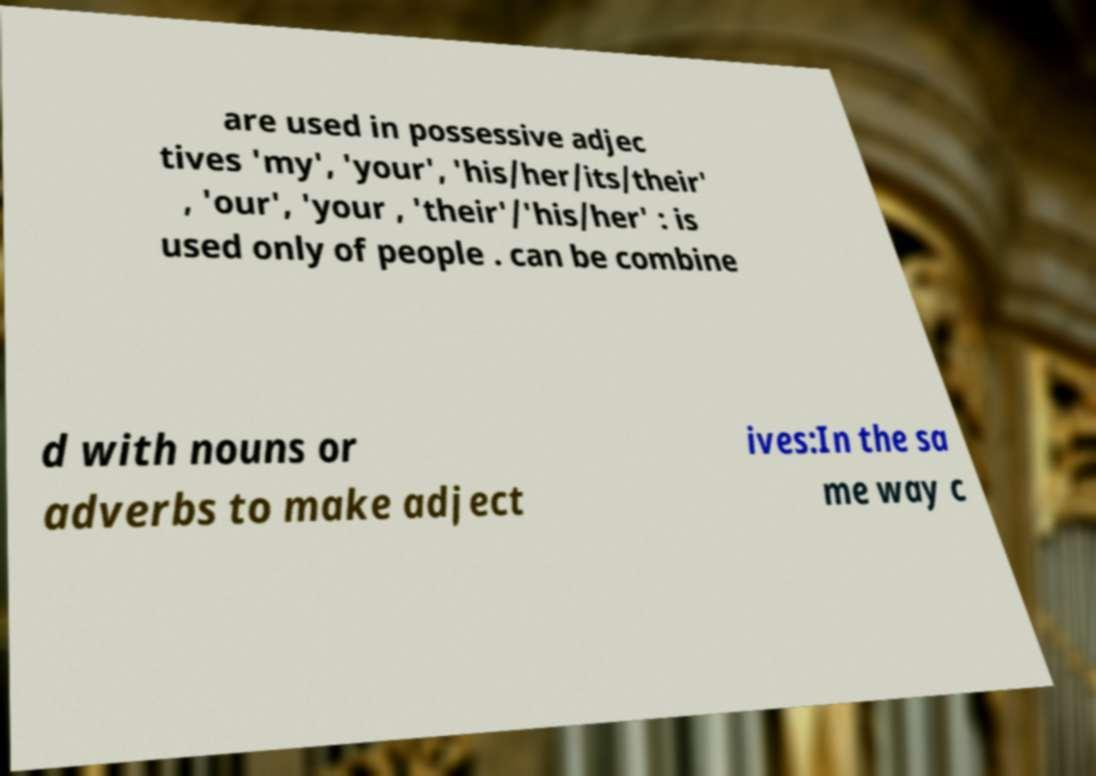What messages or text are displayed in this image? I need them in a readable, typed format. are used in possessive adjec tives 'my', 'your', 'his/her/its/their' , 'our', 'your , 'their'/'his/her' : is used only of people . can be combine d with nouns or adverbs to make adject ives:In the sa me way c 